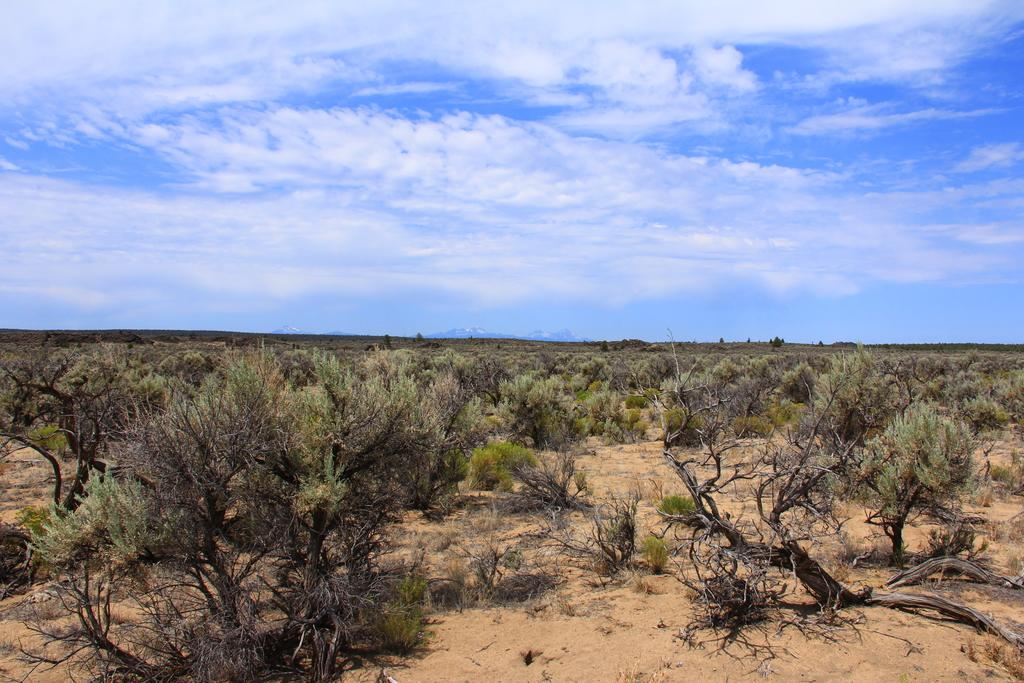What type of terrain is visible in the image? There is sand in the image, which suggests a desert or beach environment. What other natural elements can be seen in the image? There are plants and mountains visible in the image. What is visible in the sky in the image? The sky is visible in the image, and clouds are present. What type of vessel is being used to transport the eggs in the image? There are no eggs or vessels present in the image. What type of nut can be seen growing on the plants in the image? There are no nuts visible on the plants in the image. 